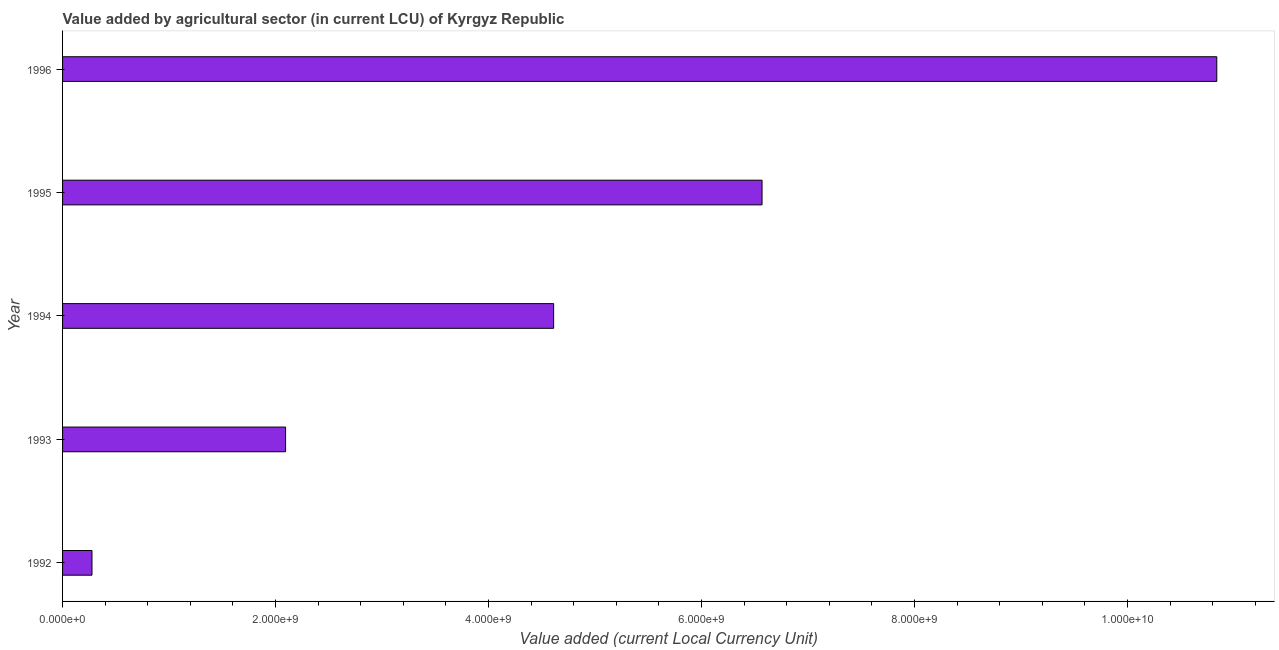Does the graph contain grids?
Your answer should be very brief. No. What is the title of the graph?
Provide a short and direct response. Value added by agricultural sector (in current LCU) of Kyrgyz Republic. What is the label or title of the X-axis?
Offer a very short reply. Value added (current Local Currency Unit). What is the label or title of the Y-axis?
Offer a very short reply. Year. What is the value added by agriculture sector in 1993?
Ensure brevity in your answer.  2.09e+09. Across all years, what is the maximum value added by agriculture sector?
Provide a short and direct response. 1.08e+1. Across all years, what is the minimum value added by agriculture sector?
Provide a short and direct response. 2.76e+08. In which year was the value added by agriculture sector minimum?
Keep it short and to the point. 1992. What is the sum of the value added by agriculture sector?
Offer a terse response. 2.44e+1. What is the difference between the value added by agriculture sector in 1993 and 1994?
Make the answer very short. -2.52e+09. What is the average value added by agriculture sector per year?
Give a very brief answer. 4.88e+09. What is the median value added by agriculture sector?
Your response must be concise. 4.61e+09. Do a majority of the years between 1993 and 1996 (inclusive) have value added by agriculture sector greater than 4800000000 LCU?
Make the answer very short. No. What is the ratio of the value added by agriculture sector in 1992 to that in 1993?
Your response must be concise. 0.13. What is the difference between the highest and the second highest value added by agriculture sector?
Your answer should be very brief. 4.27e+09. Is the sum of the value added by agriculture sector in 1992 and 1996 greater than the maximum value added by agriculture sector across all years?
Ensure brevity in your answer.  Yes. What is the difference between the highest and the lowest value added by agriculture sector?
Offer a terse response. 1.06e+1. How many years are there in the graph?
Provide a short and direct response. 5. What is the difference between two consecutive major ticks on the X-axis?
Provide a succinct answer. 2.00e+09. What is the Value added (current Local Currency Unit) of 1992?
Offer a terse response. 2.76e+08. What is the Value added (current Local Currency Unit) of 1993?
Your answer should be compact. 2.09e+09. What is the Value added (current Local Currency Unit) in 1994?
Keep it short and to the point. 4.61e+09. What is the Value added (current Local Currency Unit) in 1995?
Provide a short and direct response. 6.57e+09. What is the Value added (current Local Currency Unit) of 1996?
Offer a very short reply. 1.08e+1. What is the difference between the Value added (current Local Currency Unit) in 1992 and 1993?
Offer a very short reply. -1.82e+09. What is the difference between the Value added (current Local Currency Unit) in 1992 and 1994?
Your answer should be compact. -4.33e+09. What is the difference between the Value added (current Local Currency Unit) in 1992 and 1995?
Your answer should be compact. -6.29e+09. What is the difference between the Value added (current Local Currency Unit) in 1992 and 1996?
Offer a terse response. -1.06e+1. What is the difference between the Value added (current Local Currency Unit) in 1993 and 1994?
Ensure brevity in your answer.  -2.52e+09. What is the difference between the Value added (current Local Currency Unit) in 1993 and 1995?
Your answer should be very brief. -4.47e+09. What is the difference between the Value added (current Local Currency Unit) in 1993 and 1996?
Ensure brevity in your answer.  -8.74e+09. What is the difference between the Value added (current Local Currency Unit) in 1994 and 1995?
Make the answer very short. -1.96e+09. What is the difference between the Value added (current Local Currency Unit) in 1994 and 1996?
Provide a short and direct response. -6.23e+09. What is the difference between the Value added (current Local Currency Unit) in 1995 and 1996?
Your answer should be compact. -4.27e+09. What is the ratio of the Value added (current Local Currency Unit) in 1992 to that in 1993?
Give a very brief answer. 0.13. What is the ratio of the Value added (current Local Currency Unit) in 1992 to that in 1994?
Offer a very short reply. 0.06. What is the ratio of the Value added (current Local Currency Unit) in 1992 to that in 1995?
Your answer should be compact. 0.04. What is the ratio of the Value added (current Local Currency Unit) in 1992 to that in 1996?
Provide a short and direct response. 0.03. What is the ratio of the Value added (current Local Currency Unit) in 1993 to that in 1994?
Make the answer very short. 0.45. What is the ratio of the Value added (current Local Currency Unit) in 1993 to that in 1995?
Give a very brief answer. 0.32. What is the ratio of the Value added (current Local Currency Unit) in 1993 to that in 1996?
Ensure brevity in your answer.  0.19. What is the ratio of the Value added (current Local Currency Unit) in 1994 to that in 1995?
Ensure brevity in your answer.  0.7. What is the ratio of the Value added (current Local Currency Unit) in 1994 to that in 1996?
Keep it short and to the point. 0.42. What is the ratio of the Value added (current Local Currency Unit) in 1995 to that in 1996?
Keep it short and to the point. 0.61. 